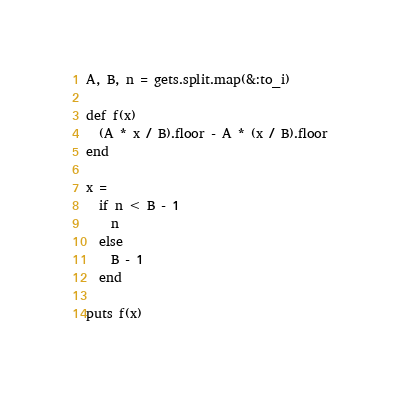Convert code to text. <code><loc_0><loc_0><loc_500><loc_500><_Ruby_>A, B, n = gets.split.map(&:to_i)

def f(x)
  (A * x / B).floor - A * (x / B).floor
end

x =
  if n < B - 1
    n
  else
    B - 1
  end

puts f(x)
</code> 